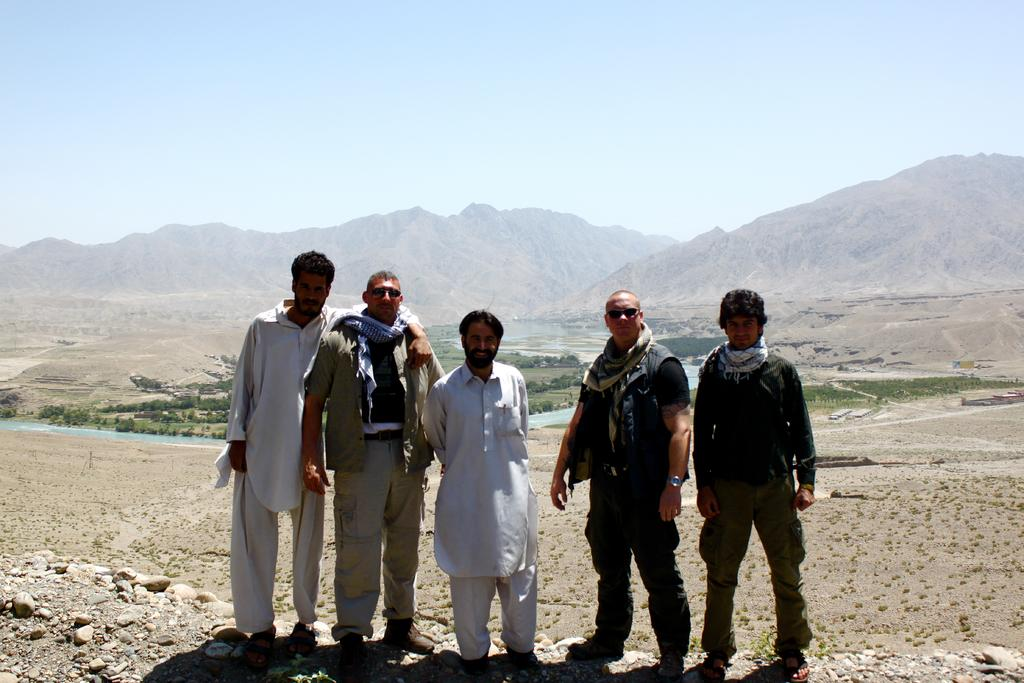How many people are standing in the image? There are five persons standing on the ground in the image. What can be seen in the background of the image? Hills are visible in the background of the image. What is visible at the top of the image? The sky is visible at the top of the image. What type of vegetation is present in the image? Trees are present in the image. What type of ground surface is visible in the image? Grass is visible in the image. What type of pies are being served to the persons in the image? There are no pies present in the image; it only shows five persons standing on the ground with hills, sky, trees, and grass visible in the background. 